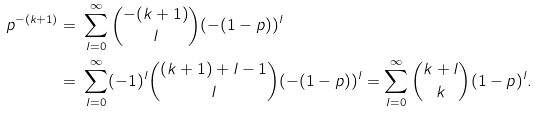Convert formula to latex. <formula><loc_0><loc_0><loc_500><loc_500>p ^ { - ( k + 1 ) } = & \ \sum _ { l = 0 } ^ { \infty } \binom { - ( k + 1 ) } { l } ( - ( 1 - p ) ) ^ { l } \\ = & \ \sum _ { l = 0 } ^ { \infty } ( - 1 ) ^ { l } \binom { ( k + 1 ) + l - 1 } { l } ( - ( 1 - p ) ) ^ { l } = \sum _ { l = 0 } ^ { \infty } \binom { k + l } { k } ( 1 - p ) ^ { l } .</formula> 